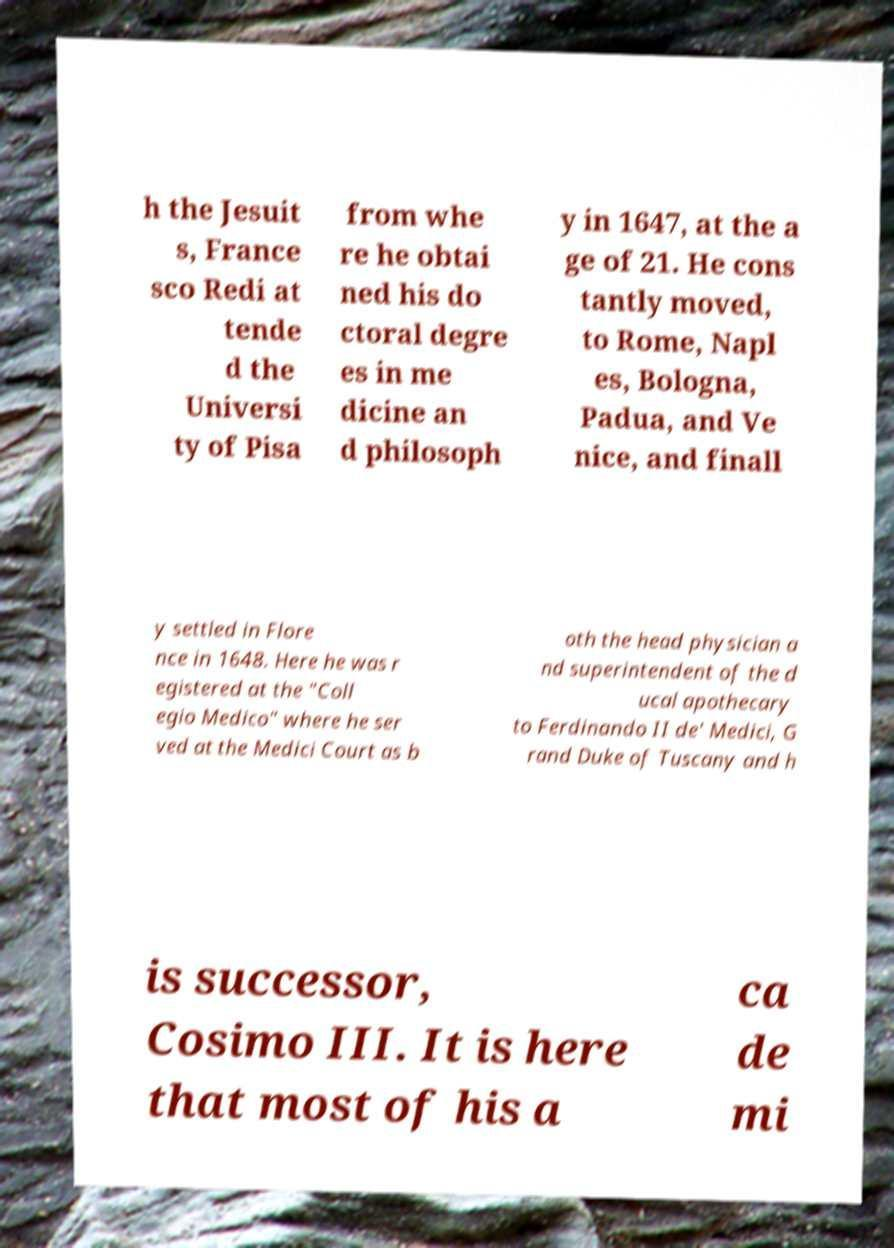Please read and relay the text visible in this image. What does it say? h the Jesuit s, France sco Redi at tende d the Universi ty of Pisa from whe re he obtai ned his do ctoral degre es in me dicine an d philosoph y in 1647, at the a ge of 21. He cons tantly moved, to Rome, Napl es, Bologna, Padua, and Ve nice, and finall y settled in Flore nce in 1648. Here he was r egistered at the "Coll egio Medico" where he ser ved at the Medici Court as b oth the head physician a nd superintendent of the d ucal apothecary to Ferdinando II de' Medici, G rand Duke of Tuscany and h is successor, Cosimo III. It is here that most of his a ca de mi 